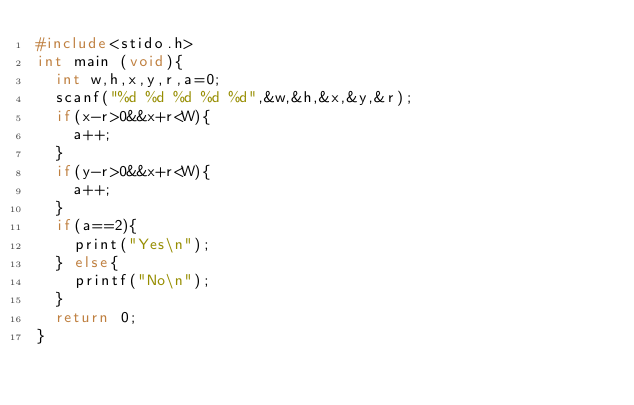Convert code to text. <code><loc_0><loc_0><loc_500><loc_500><_C_>#include<stido.h>
int main (void){
  int w,h,x,y,r,a=0;
  scanf("%d %d %d %d %d",&w,&h,&x,&y,&r);
  if(x-r>0&&x+r<W){
    a++;
  }
  if(y-r>0&&x+r<W){
    a++;
  }
  if(a==2){
    print("Yes\n");
  } else{
    printf("No\n");
  }
  return 0;
}</code> 